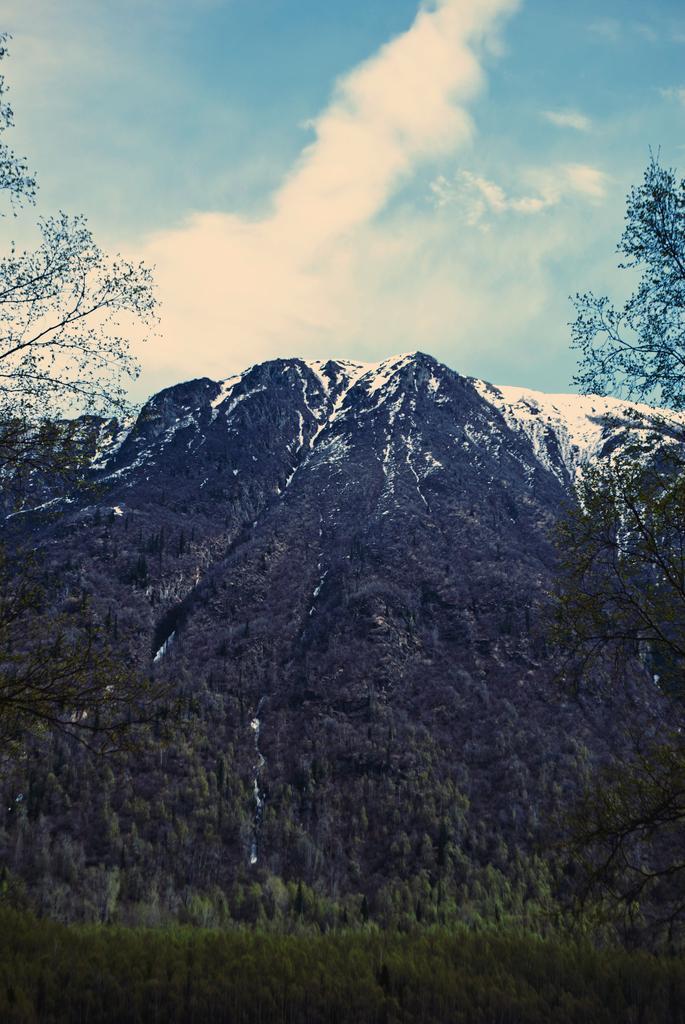Describe this image in one or two sentences. This image consists of mountains covered with plants. On which there is snow. At the top, there are clouds in the sky. 